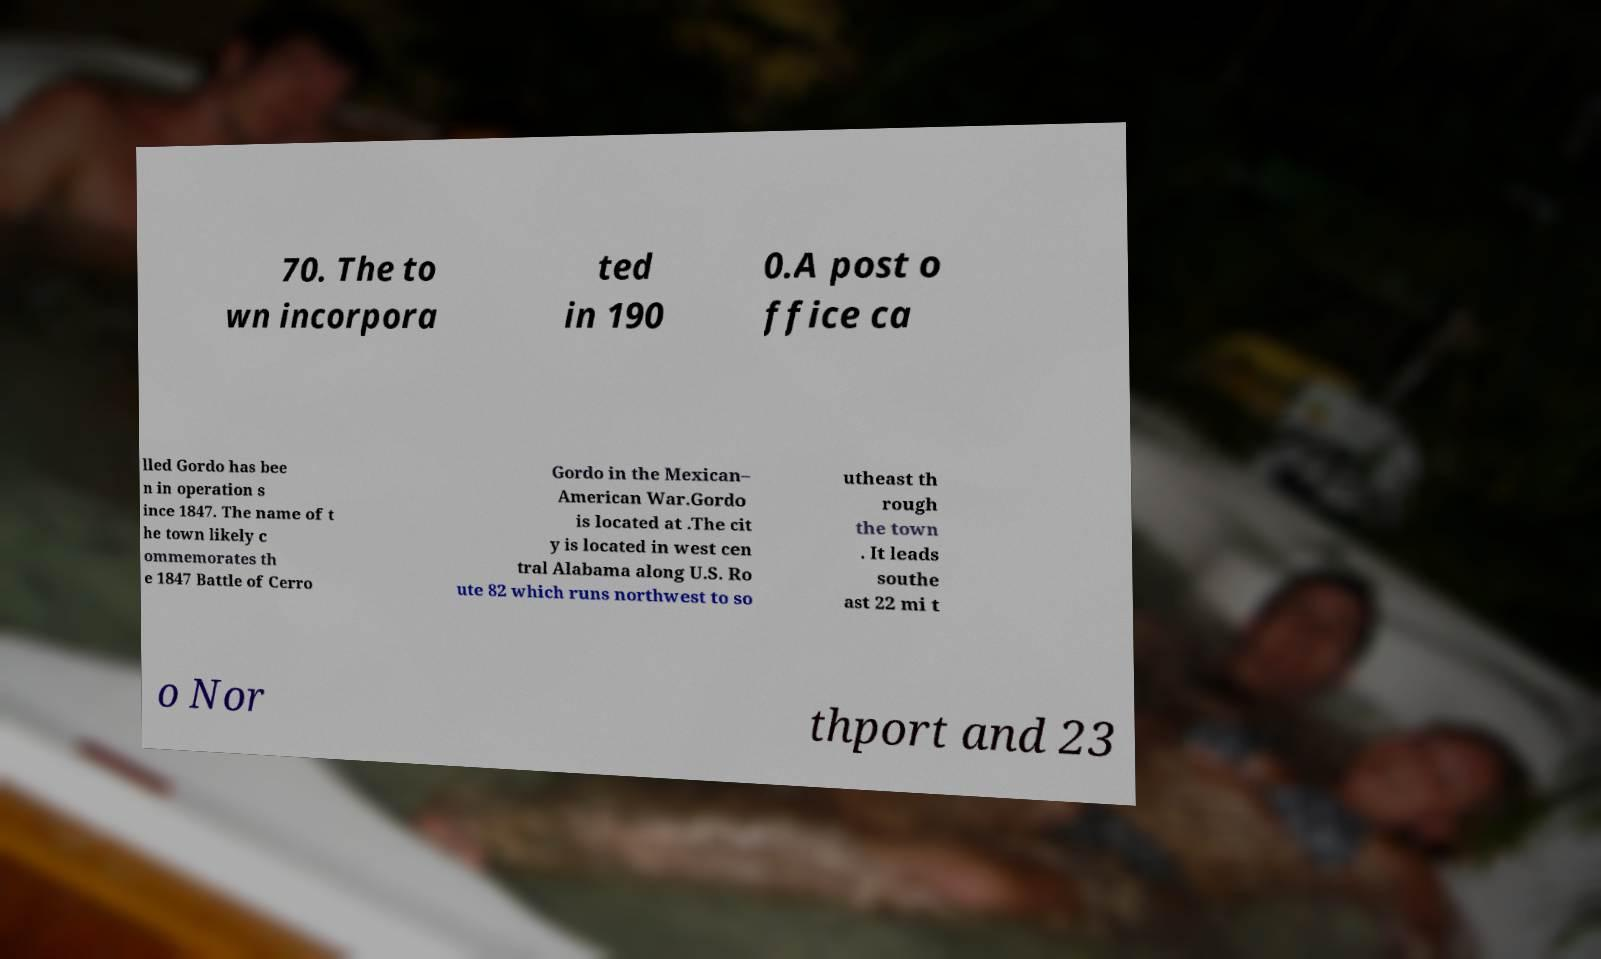For documentation purposes, I need the text within this image transcribed. Could you provide that? 70. The to wn incorpora ted in 190 0.A post o ffice ca lled Gordo has bee n in operation s ince 1847. The name of t he town likely c ommemorates th e 1847 Battle of Cerro Gordo in the Mexican– American War.Gordo is located at .The cit y is located in west cen tral Alabama along U.S. Ro ute 82 which runs northwest to so utheast th rough the town . It leads southe ast 22 mi t o Nor thport and 23 